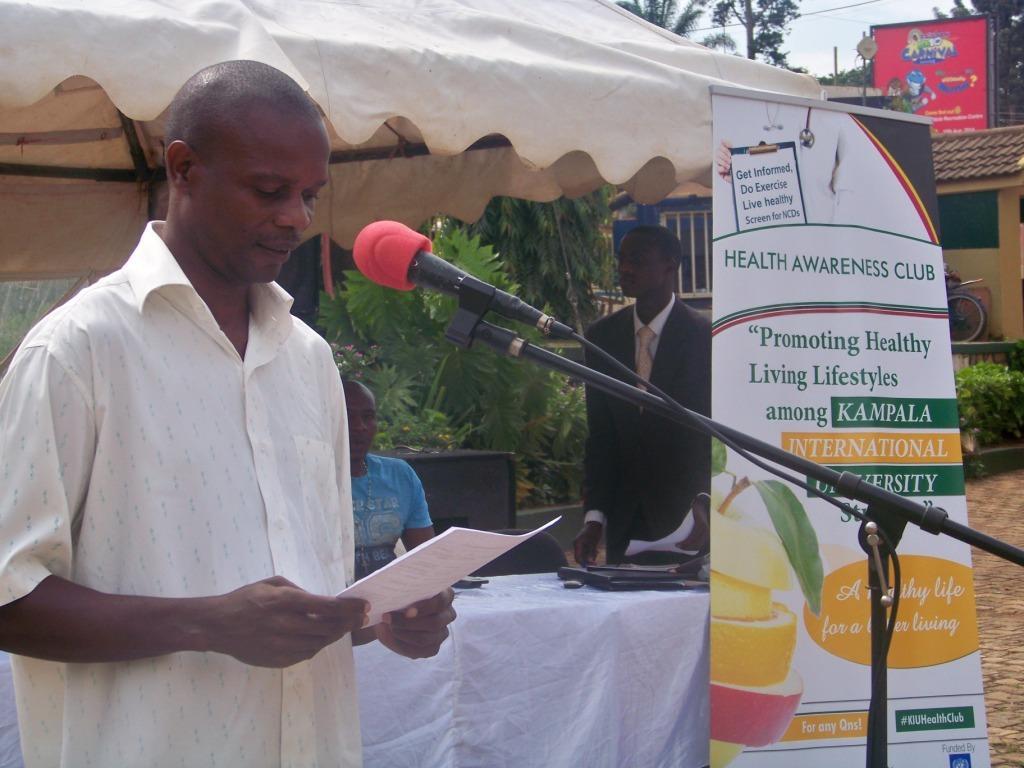How would you summarize this image in a sentence or two? In this image I can see three persons where one is sitting and two are standing. I can also see two men are holding white colour papers. On the right side of the image I can see a mic, few boards and on these boards I can see something is written. In the background I can see a table, a white colour table cloth on it, few plants, few buildings, number of trees and a white tent shed. On the right side of the image I can see a bicycle. 